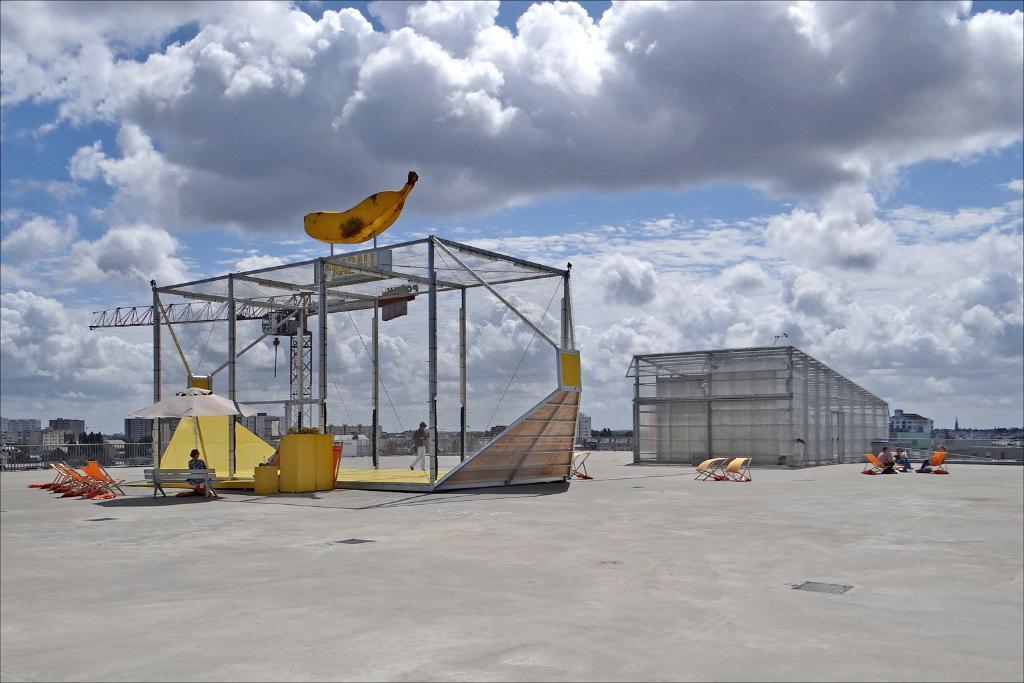Could you give a brief overview of what you see in this image? This is an outside view. Here I can see two sheds on the ground. On the right side, I can see few people are sitting on the chairs. On the left side there is one person sitting on the bench and there are few empty chairs. In the background, I can see many buildings. At the top of the image I can see the sky and clouds. 